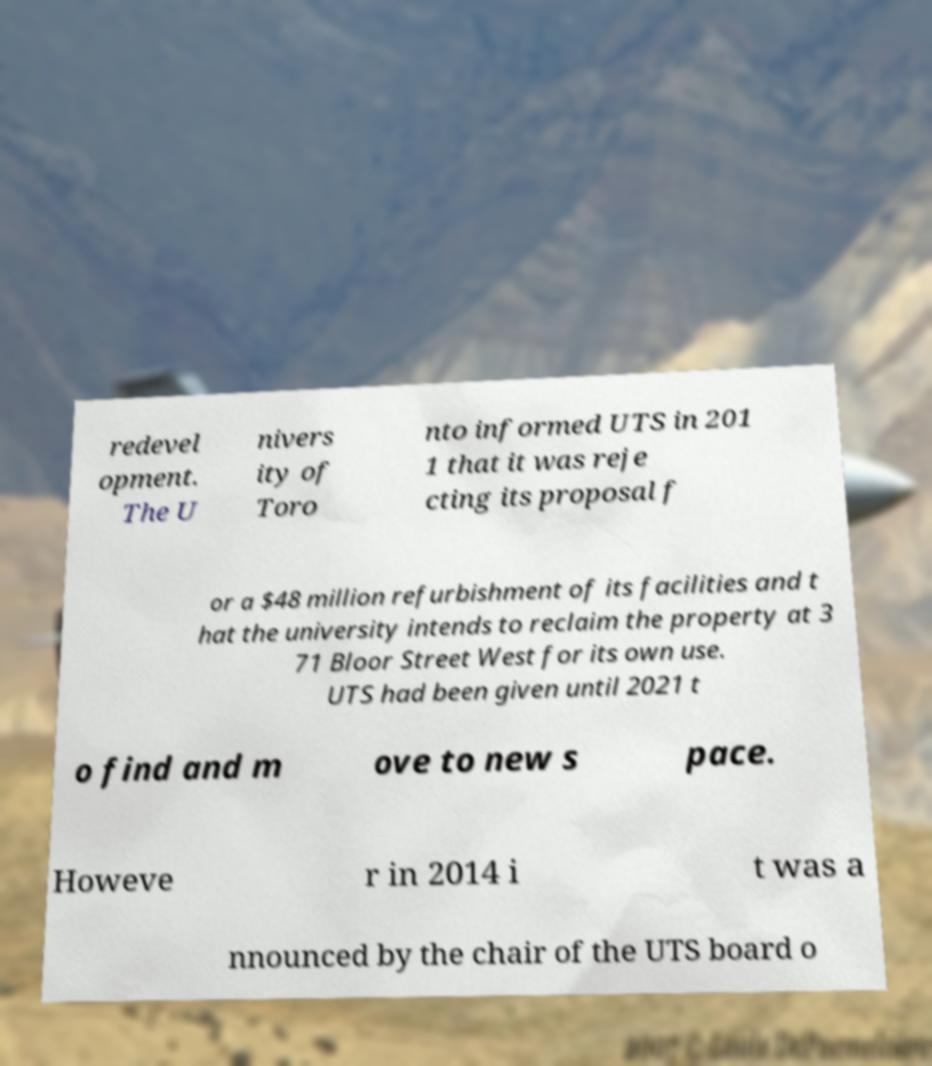Please identify and transcribe the text found in this image. redevel opment. The U nivers ity of Toro nto informed UTS in 201 1 that it was reje cting its proposal f or a $48 million refurbishment of its facilities and t hat the university intends to reclaim the property at 3 71 Bloor Street West for its own use. UTS had been given until 2021 t o find and m ove to new s pace. Howeve r in 2014 i t was a nnounced by the chair of the UTS board o 